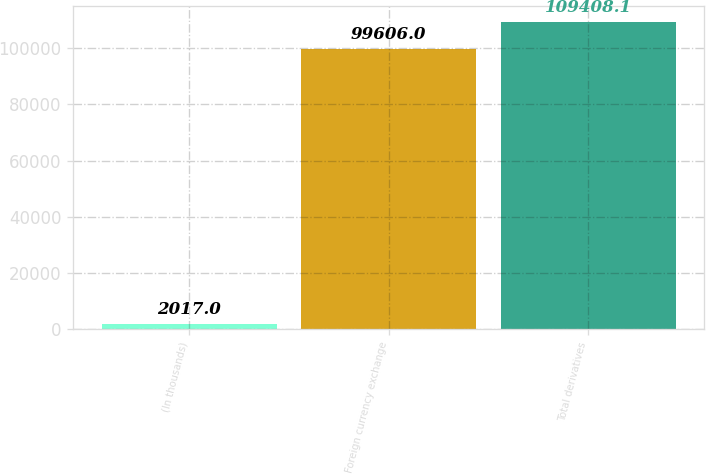Convert chart. <chart><loc_0><loc_0><loc_500><loc_500><bar_chart><fcel>(In thousands)<fcel>Foreign currency exchange<fcel>Total derivatives<nl><fcel>2017<fcel>99606<fcel>109408<nl></chart> 